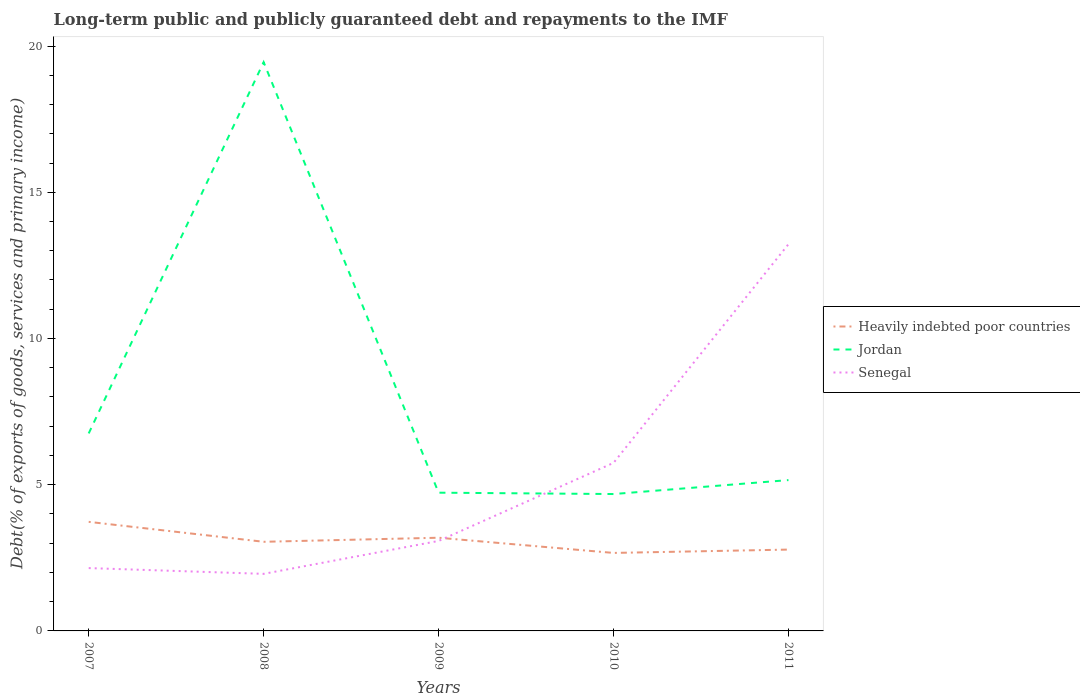Is the number of lines equal to the number of legend labels?
Your response must be concise. Yes. Across all years, what is the maximum debt and repayments in Heavily indebted poor countries?
Offer a terse response. 2.67. In which year was the debt and repayments in Jordan maximum?
Offer a very short reply. 2010. What is the total debt and repayments in Jordan in the graph?
Provide a succinct answer. 14.29. What is the difference between the highest and the second highest debt and repayments in Senegal?
Give a very brief answer. 11.27. What is the difference between the highest and the lowest debt and repayments in Heavily indebted poor countries?
Ensure brevity in your answer.  2. Is the debt and repayments in Heavily indebted poor countries strictly greater than the debt and repayments in Jordan over the years?
Keep it short and to the point. Yes. How many lines are there?
Your answer should be very brief. 3. How many years are there in the graph?
Your response must be concise. 5. Does the graph contain any zero values?
Offer a very short reply. No. Does the graph contain grids?
Provide a succinct answer. No. How many legend labels are there?
Ensure brevity in your answer.  3. How are the legend labels stacked?
Your response must be concise. Vertical. What is the title of the graph?
Offer a very short reply. Long-term public and publicly guaranteed debt and repayments to the IMF. What is the label or title of the Y-axis?
Ensure brevity in your answer.  Debt(% of exports of goods, services and primary income). What is the Debt(% of exports of goods, services and primary income) in Heavily indebted poor countries in 2007?
Make the answer very short. 3.73. What is the Debt(% of exports of goods, services and primary income) in Jordan in 2007?
Keep it short and to the point. 6.75. What is the Debt(% of exports of goods, services and primary income) of Senegal in 2007?
Your answer should be very brief. 2.15. What is the Debt(% of exports of goods, services and primary income) in Heavily indebted poor countries in 2008?
Keep it short and to the point. 3.05. What is the Debt(% of exports of goods, services and primary income) of Jordan in 2008?
Keep it short and to the point. 19.45. What is the Debt(% of exports of goods, services and primary income) in Senegal in 2008?
Ensure brevity in your answer.  1.95. What is the Debt(% of exports of goods, services and primary income) of Heavily indebted poor countries in 2009?
Your answer should be very brief. 3.19. What is the Debt(% of exports of goods, services and primary income) in Jordan in 2009?
Your answer should be compact. 4.73. What is the Debt(% of exports of goods, services and primary income) in Senegal in 2009?
Ensure brevity in your answer.  3.08. What is the Debt(% of exports of goods, services and primary income) in Heavily indebted poor countries in 2010?
Offer a terse response. 2.67. What is the Debt(% of exports of goods, services and primary income) in Jordan in 2010?
Your answer should be very brief. 4.68. What is the Debt(% of exports of goods, services and primary income) in Senegal in 2010?
Your response must be concise. 5.75. What is the Debt(% of exports of goods, services and primary income) of Heavily indebted poor countries in 2011?
Provide a short and direct response. 2.78. What is the Debt(% of exports of goods, services and primary income) of Jordan in 2011?
Give a very brief answer. 5.16. What is the Debt(% of exports of goods, services and primary income) in Senegal in 2011?
Your answer should be compact. 13.22. Across all years, what is the maximum Debt(% of exports of goods, services and primary income) in Heavily indebted poor countries?
Ensure brevity in your answer.  3.73. Across all years, what is the maximum Debt(% of exports of goods, services and primary income) in Jordan?
Provide a short and direct response. 19.45. Across all years, what is the maximum Debt(% of exports of goods, services and primary income) of Senegal?
Keep it short and to the point. 13.22. Across all years, what is the minimum Debt(% of exports of goods, services and primary income) of Heavily indebted poor countries?
Offer a terse response. 2.67. Across all years, what is the minimum Debt(% of exports of goods, services and primary income) in Jordan?
Make the answer very short. 4.68. Across all years, what is the minimum Debt(% of exports of goods, services and primary income) in Senegal?
Make the answer very short. 1.95. What is the total Debt(% of exports of goods, services and primary income) of Heavily indebted poor countries in the graph?
Offer a very short reply. 15.41. What is the total Debt(% of exports of goods, services and primary income) in Jordan in the graph?
Your answer should be very brief. 40.77. What is the total Debt(% of exports of goods, services and primary income) in Senegal in the graph?
Give a very brief answer. 26.15. What is the difference between the Debt(% of exports of goods, services and primary income) in Heavily indebted poor countries in 2007 and that in 2008?
Make the answer very short. 0.68. What is the difference between the Debt(% of exports of goods, services and primary income) in Jordan in 2007 and that in 2008?
Provide a short and direct response. -12.7. What is the difference between the Debt(% of exports of goods, services and primary income) of Senegal in 2007 and that in 2008?
Give a very brief answer. 0.2. What is the difference between the Debt(% of exports of goods, services and primary income) in Heavily indebted poor countries in 2007 and that in 2009?
Your answer should be compact. 0.54. What is the difference between the Debt(% of exports of goods, services and primary income) of Jordan in 2007 and that in 2009?
Provide a succinct answer. 2.03. What is the difference between the Debt(% of exports of goods, services and primary income) of Senegal in 2007 and that in 2009?
Make the answer very short. -0.93. What is the difference between the Debt(% of exports of goods, services and primary income) of Heavily indebted poor countries in 2007 and that in 2010?
Your answer should be very brief. 1.06. What is the difference between the Debt(% of exports of goods, services and primary income) in Jordan in 2007 and that in 2010?
Give a very brief answer. 2.07. What is the difference between the Debt(% of exports of goods, services and primary income) in Senegal in 2007 and that in 2010?
Your answer should be very brief. -3.6. What is the difference between the Debt(% of exports of goods, services and primary income) in Heavily indebted poor countries in 2007 and that in 2011?
Provide a succinct answer. 0.95. What is the difference between the Debt(% of exports of goods, services and primary income) of Jordan in 2007 and that in 2011?
Your answer should be compact. 1.6. What is the difference between the Debt(% of exports of goods, services and primary income) of Senegal in 2007 and that in 2011?
Your response must be concise. -11.08. What is the difference between the Debt(% of exports of goods, services and primary income) in Heavily indebted poor countries in 2008 and that in 2009?
Give a very brief answer. -0.14. What is the difference between the Debt(% of exports of goods, services and primary income) in Jordan in 2008 and that in 2009?
Give a very brief answer. 14.72. What is the difference between the Debt(% of exports of goods, services and primary income) of Senegal in 2008 and that in 2009?
Give a very brief answer. -1.13. What is the difference between the Debt(% of exports of goods, services and primary income) in Heavily indebted poor countries in 2008 and that in 2010?
Your answer should be compact. 0.38. What is the difference between the Debt(% of exports of goods, services and primary income) of Jordan in 2008 and that in 2010?
Offer a very short reply. 14.77. What is the difference between the Debt(% of exports of goods, services and primary income) in Senegal in 2008 and that in 2010?
Ensure brevity in your answer.  -3.8. What is the difference between the Debt(% of exports of goods, services and primary income) of Heavily indebted poor countries in 2008 and that in 2011?
Give a very brief answer. 0.27. What is the difference between the Debt(% of exports of goods, services and primary income) in Jordan in 2008 and that in 2011?
Ensure brevity in your answer.  14.29. What is the difference between the Debt(% of exports of goods, services and primary income) in Senegal in 2008 and that in 2011?
Your answer should be very brief. -11.27. What is the difference between the Debt(% of exports of goods, services and primary income) of Heavily indebted poor countries in 2009 and that in 2010?
Your answer should be compact. 0.52. What is the difference between the Debt(% of exports of goods, services and primary income) of Jordan in 2009 and that in 2010?
Provide a succinct answer. 0.05. What is the difference between the Debt(% of exports of goods, services and primary income) of Senegal in 2009 and that in 2010?
Offer a very short reply. -2.67. What is the difference between the Debt(% of exports of goods, services and primary income) of Heavily indebted poor countries in 2009 and that in 2011?
Keep it short and to the point. 0.41. What is the difference between the Debt(% of exports of goods, services and primary income) of Jordan in 2009 and that in 2011?
Make the answer very short. -0.43. What is the difference between the Debt(% of exports of goods, services and primary income) of Senegal in 2009 and that in 2011?
Ensure brevity in your answer.  -10.15. What is the difference between the Debt(% of exports of goods, services and primary income) of Heavily indebted poor countries in 2010 and that in 2011?
Offer a terse response. -0.11. What is the difference between the Debt(% of exports of goods, services and primary income) in Jordan in 2010 and that in 2011?
Keep it short and to the point. -0.48. What is the difference between the Debt(% of exports of goods, services and primary income) of Senegal in 2010 and that in 2011?
Your response must be concise. -7.48. What is the difference between the Debt(% of exports of goods, services and primary income) of Heavily indebted poor countries in 2007 and the Debt(% of exports of goods, services and primary income) of Jordan in 2008?
Give a very brief answer. -15.72. What is the difference between the Debt(% of exports of goods, services and primary income) of Heavily indebted poor countries in 2007 and the Debt(% of exports of goods, services and primary income) of Senegal in 2008?
Make the answer very short. 1.78. What is the difference between the Debt(% of exports of goods, services and primary income) of Jordan in 2007 and the Debt(% of exports of goods, services and primary income) of Senegal in 2008?
Your answer should be compact. 4.8. What is the difference between the Debt(% of exports of goods, services and primary income) in Heavily indebted poor countries in 2007 and the Debt(% of exports of goods, services and primary income) in Jordan in 2009?
Your answer should be very brief. -1. What is the difference between the Debt(% of exports of goods, services and primary income) in Heavily indebted poor countries in 2007 and the Debt(% of exports of goods, services and primary income) in Senegal in 2009?
Your answer should be compact. 0.65. What is the difference between the Debt(% of exports of goods, services and primary income) of Jordan in 2007 and the Debt(% of exports of goods, services and primary income) of Senegal in 2009?
Offer a terse response. 3.68. What is the difference between the Debt(% of exports of goods, services and primary income) in Heavily indebted poor countries in 2007 and the Debt(% of exports of goods, services and primary income) in Jordan in 2010?
Offer a terse response. -0.95. What is the difference between the Debt(% of exports of goods, services and primary income) of Heavily indebted poor countries in 2007 and the Debt(% of exports of goods, services and primary income) of Senegal in 2010?
Offer a very short reply. -2.02. What is the difference between the Debt(% of exports of goods, services and primary income) in Heavily indebted poor countries in 2007 and the Debt(% of exports of goods, services and primary income) in Jordan in 2011?
Ensure brevity in your answer.  -1.43. What is the difference between the Debt(% of exports of goods, services and primary income) of Heavily indebted poor countries in 2007 and the Debt(% of exports of goods, services and primary income) of Senegal in 2011?
Your answer should be compact. -9.49. What is the difference between the Debt(% of exports of goods, services and primary income) of Jordan in 2007 and the Debt(% of exports of goods, services and primary income) of Senegal in 2011?
Offer a terse response. -6.47. What is the difference between the Debt(% of exports of goods, services and primary income) in Heavily indebted poor countries in 2008 and the Debt(% of exports of goods, services and primary income) in Jordan in 2009?
Give a very brief answer. -1.68. What is the difference between the Debt(% of exports of goods, services and primary income) of Heavily indebted poor countries in 2008 and the Debt(% of exports of goods, services and primary income) of Senegal in 2009?
Ensure brevity in your answer.  -0.03. What is the difference between the Debt(% of exports of goods, services and primary income) in Jordan in 2008 and the Debt(% of exports of goods, services and primary income) in Senegal in 2009?
Make the answer very short. 16.37. What is the difference between the Debt(% of exports of goods, services and primary income) of Heavily indebted poor countries in 2008 and the Debt(% of exports of goods, services and primary income) of Jordan in 2010?
Offer a terse response. -1.63. What is the difference between the Debt(% of exports of goods, services and primary income) of Heavily indebted poor countries in 2008 and the Debt(% of exports of goods, services and primary income) of Senegal in 2010?
Offer a very short reply. -2.7. What is the difference between the Debt(% of exports of goods, services and primary income) in Jordan in 2008 and the Debt(% of exports of goods, services and primary income) in Senegal in 2010?
Offer a terse response. 13.7. What is the difference between the Debt(% of exports of goods, services and primary income) of Heavily indebted poor countries in 2008 and the Debt(% of exports of goods, services and primary income) of Jordan in 2011?
Your response must be concise. -2.11. What is the difference between the Debt(% of exports of goods, services and primary income) in Heavily indebted poor countries in 2008 and the Debt(% of exports of goods, services and primary income) in Senegal in 2011?
Offer a terse response. -10.18. What is the difference between the Debt(% of exports of goods, services and primary income) in Jordan in 2008 and the Debt(% of exports of goods, services and primary income) in Senegal in 2011?
Ensure brevity in your answer.  6.22. What is the difference between the Debt(% of exports of goods, services and primary income) of Heavily indebted poor countries in 2009 and the Debt(% of exports of goods, services and primary income) of Jordan in 2010?
Your answer should be compact. -1.49. What is the difference between the Debt(% of exports of goods, services and primary income) of Heavily indebted poor countries in 2009 and the Debt(% of exports of goods, services and primary income) of Senegal in 2010?
Your answer should be very brief. -2.56. What is the difference between the Debt(% of exports of goods, services and primary income) of Jordan in 2009 and the Debt(% of exports of goods, services and primary income) of Senegal in 2010?
Provide a short and direct response. -1.02. What is the difference between the Debt(% of exports of goods, services and primary income) of Heavily indebted poor countries in 2009 and the Debt(% of exports of goods, services and primary income) of Jordan in 2011?
Offer a very short reply. -1.97. What is the difference between the Debt(% of exports of goods, services and primary income) of Heavily indebted poor countries in 2009 and the Debt(% of exports of goods, services and primary income) of Senegal in 2011?
Offer a very short reply. -10.04. What is the difference between the Debt(% of exports of goods, services and primary income) in Jordan in 2009 and the Debt(% of exports of goods, services and primary income) in Senegal in 2011?
Keep it short and to the point. -8.5. What is the difference between the Debt(% of exports of goods, services and primary income) in Heavily indebted poor countries in 2010 and the Debt(% of exports of goods, services and primary income) in Jordan in 2011?
Provide a succinct answer. -2.49. What is the difference between the Debt(% of exports of goods, services and primary income) of Heavily indebted poor countries in 2010 and the Debt(% of exports of goods, services and primary income) of Senegal in 2011?
Give a very brief answer. -10.56. What is the difference between the Debt(% of exports of goods, services and primary income) in Jordan in 2010 and the Debt(% of exports of goods, services and primary income) in Senegal in 2011?
Make the answer very short. -8.54. What is the average Debt(% of exports of goods, services and primary income) in Heavily indebted poor countries per year?
Make the answer very short. 3.08. What is the average Debt(% of exports of goods, services and primary income) in Jordan per year?
Give a very brief answer. 8.15. What is the average Debt(% of exports of goods, services and primary income) of Senegal per year?
Your answer should be compact. 5.23. In the year 2007, what is the difference between the Debt(% of exports of goods, services and primary income) in Heavily indebted poor countries and Debt(% of exports of goods, services and primary income) in Jordan?
Keep it short and to the point. -3.02. In the year 2007, what is the difference between the Debt(% of exports of goods, services and primary income) of Heavily indebted poor countries and Debt(% of exports of goods, services and primary income) of Senegal?
Offer a terse response. 1.58. In the year 2007, what is the difference between the Debt(% of exports of goods, services and primary income) in Jordan and Debt(% of exports of goods, services and primary income) in Senegal?
Keep it short and to the point. 4.6. In the year 2008, what is the difference between the Debt(% of exports of goods, services and primary income) of Heavily indebted poor countries and Debt(% of exports of goods, services and primary income) of Jordan?
Your answer should be compact. -16.4. In the year 2008, what is the difference between the Debt(% of exports of goods, services and primary income) of Heavily indebted poor countries and Debt(% of exports of goods, services and primary income) of Senegal?
Your answer should be very brief. 1.1. In the year 2008, what is the difference between the Debt(% of exports of goods, services and primary income) in Jordan and Debt(% of exports of goods, services and primary income) in Senegal?
Your answer should be very brief. 17.5. In the year 2009, what is the difference between the Debt(% of exports of goods, services and primary income) of Heavily indebted poor countries and Debt(% of exports of goods, services and primary income) of Jordan?
Offer a very short reply. -1.54. In the year 2009, what is the difference between the Debt(% of exports of goods, services and primary income) in Heavily indebted poor countries and Debt(% of exports of goods, services and primary income) in Senegal?
Offer a terse response. 0.11. In the year 2009, what is the difference between the Debt(% of exports of goods, services and primary income) of Jordan and Debt(% of exports of goods, services and primary income) of Senegal?
Your answer should be compact. 1.65. In the year 2010, what is the difference between the Debt(% of exports of goods, services and primary income) in Heavily indebted poor countries and Debt(% of exports of goods, services and primary income) in Jordan?
Offer a terse response. -2.01. In the year 2010, what is the difference between the Debt(% of exports of goods, services and primary income) of Heavily indebted poor countries and Debt(% of exports of goods, services and primary income) of Senegal?
Provide a short and direct response. -3.08. In the year 2010, what is the difference between the Debt(% of exports of goods, services and primary income) of Jordan and Debt(% of exports of goods, services and primary income) of Senegal?
Your response must be concise. -1.07. In the year 2011, what is the difference between the Debt(% of exports of goods, services and primary income) of Heavily indebted poor countries and Debt(% of exports of goods, services and primary income) of Jordan?
Your answer should be compact. -2.38. In the year 2011, what is the difference between the Debt(% of exports of goods, services and primary income) of Heavily indebted poor countries and Debt(% of exports of goods, services and primary income) of Senegal?
Your answer should be very brief. -10.44. In the year 2011, what is the difference between the Debt(% of exports of goods, services and primary income) in Jordan and Debt(% of exports of goods, services and primary income) in Senegal?
Offer a terse response. -8.07. What is the ratio of the Debt(% of exports of goods, services and primary income) of Heavily indebted poor countries in 2007 to that in 2008?
Keep it short and to the point. 1.22. What is the ratio of the Debt(% of exports of goods, services and primary income) in Jordan in 2007 to that in 2008?
Offer a terse response. 0.35. What is the ratio of the Debt(% of exports of goods, services and primary income) in Senegal in 2007 to that in 2008?
Ensure brevity in your answer.  1.1. What is the ratio of the Debt(% of exports of goods, services and primary income) of Heavily indebted poor countries in 2007 to that in 2009?
Offer a very short reply. 1.17. What is the ratio of the Debt(% of exports of goods, services and primary income) of Jordan in 2007 to that in 2009?
Your answer should be compact. 1.43. What is the ratio of the Debt(% of exports of goods, services and primary income) of Senegal in 2007 to that in 2009?
Provide a short and direct response. 0.7. What is the ratio of the Debt(% of exports of goods, services and primary income) in Heavily indebted poor countries in 2007 to that in 2010?
Keep it short and to the point. 1.4. What is the ratio of the Debt(% of exports of goods, services and primary income) of Jordan in 2007 to that in 2010?
Keep it short and to the point. 1.44. What is the ratio of the Debt(% of exports of goods, services and primary income) of Senegal in 2007 to that in 2010?
Give a very brief answer. 0.37. What is the ratio of the Debt(% of exports of goods, services and primary income) of Heavily indebted poor countries in 2007 to that in 2011?
Give a very brief answer. 1.34. What is the ratio of the Debt(% of exports of goods, services and primary income) in Jordan in 2007 to that in 2011?
Give a very brief answer. 1.31. What is the ratio of the Debt(% of exports of goods, services and primary income) of Senegal in 2007 to that in 2011?
Give a very brief answer. 0.16. What is the ratio of the Debt(% of exports of goods, services and primary income) of Heavily indebted poor countries in 2008 to that in 2009?
Offer a terse response. 0.96. What is the ratio of the Debt(% of exports of goods, services and primary income) in Jordan in 2008 to that in 2009?
Your answer should be very brief. 4.11. What is the ratio of the Debt(% of exports of goods, services and primary income) in Senegal in 2008 to that in 2009?
Your response must be concise. 0.63. What is the ratio of the Debt(% of exports of goods, services and primary income) of Heavily indebted poor countries in 2008 to that in 2010?
Keep it short and to the point. 1.14. What is the ratio of the Debt(% of exports of goods, services and primary income) of Jordan in 2008 to that in 2010?
Your response must be concise. 4.16. What is the ratio of the Debt(% of exports of goods, services and primary income) in Senegal in 2008 to that in 2010?
Your response must be concise. 0.34. What is the ratio of the Debt(% of exports of goods, services and primary income) in Heavily indebted poor countries in 2008 to that in 2011?
Your answer should be compact. 1.1. What is the ratio of the Debt(% of exports of goods, services and primary income) of Jordan in 2008 to that in 2011?
Provide a short and direct response. 3.77. What is the ratio of the Debt(% of exports of goods, services and primary income) in Senegal in 2008 to that in 2011?
Your answer should be compact. 0.15. What is the ratio of the Debt(% of exports of goods, services and primary income) in Heavily indebted poor countries in 2009 to that in 2010?
Provide a succinct answer. 1.19. What is the ratio of the Debt(% of exports of goods, services and primary income) of Jordan in 2009 to that in 2010?
Your response must be concise. 1.01. What is the ratio of the Debt(% of exports of goods, services and primary income) in Senegal in 2009 to that in 2010?
Give a very brief answer. 0.54. What is the ratio of the Debt(% of exports of goods, services and primary income) of Heavily indebted poor countries in 2009 to that in 2011?
Offer a terse response. 1.15. What is the ratio of the Debt(% of exports of goods, services and primary income) of Jordan in 2009 to that in 2011?
Your answer should be very brief. 0.92. What is the ratio of the Debt(% of exports of goods, services and primary income) in Senegal in 2009 to that in 2011?
Provide a succinct answer. 0.23. What is the ratio of the Debt(% of exports of goods, services and primary income) in Heavily indebted poor countries in 2010 to that in 2011?
Your answer should be very brief. 0.96. What is the ratio of the Debt(% of exports of goods, services and primary income) of Jordan in 2010 to that in 2011?
Keep it short and to the point. 0.91. What is the ratio of the Debt(% of exports of goods, services and primary income) in Senegal in 2010 to that in 2011?
Offer a terse response. 0.43. What is the difference between the highest and the second highest Debt(% of exports of goods, services and primary income) in Heavily indebted poor countries?
Your answer should be compact. 0.54. What is the difference between the highest and the second highest Debt(% of exports of goods, services and primary income) of Jordan?
Give a very brief answer. 12.7. What is the difference between the highest and the second highest Debt(% of exports of goods, services and primary income) of Senegal?
Offer a very short reply. 7.48. What is the difference between the highest and the lowest Debt(% of exports of goods, services and primary income) in Heavily indebted poor countries?
Your response must be concise. 1.06. What is the difference between the highest and the lowest Debt(% of exports of goods, services and primary income) of Jordan?
Ensure brevity in your answer.  14.77. What is the difference between the highest and the lowest Debt(% of exports of goods, services and primary income) of Senegal?
Your answer should be compact. 11.27. 